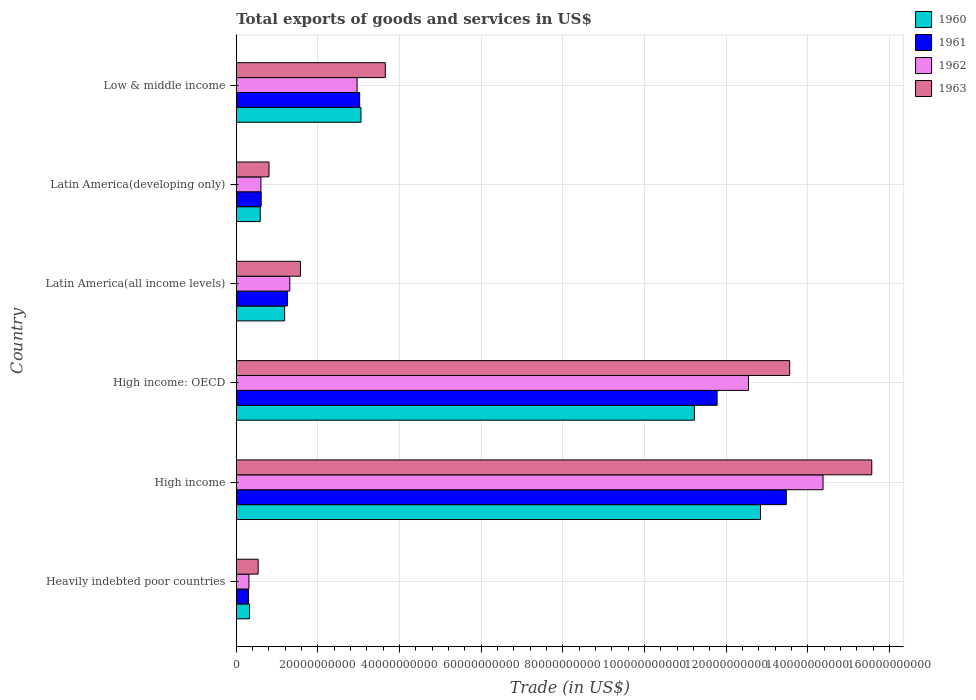Are the number of bars on each tick of the Y-axis equal?
Provide a short and direct response. Yes. How many bars are there on the 2nd tick from the top?
Offer a terse response. 4. What is the label of the 2nd group of bars from the top?
Your response must be concise. Latin America(developing only). What is the total exports of goods and services in 1963 in Latin America(developing only)?
Give a very brief answer. 8.02e+09. Across all countries, what is the maximum total exports of goods and services in 1963?
Offer a very short reply. 1.56e+11. Across all countries, what is the minimum total exports of goods and services in 1962?
Offer a terse response. 3.11e+09. In which country was the total exports of goods and services in 1960 maximum?
Offer a terse response. High income. In which country was the total exports of goods and services in 1963 minimum?
Your response must be concise. Heavily indebted poor countries. What is the total total exports of goods and services in 1961 in the graph?
Make the answer very short. 3.04e+11. What is the difference between the total exports of goods and services in 1960 in High income: OECD and that in Latin America(all income levels)?
Your answer should be very brief. 1.00e+11. What is the difference between the total exports of goods and services in 1960 in Heavily indebted poor countries and the total exports of goods and services in 1962 in Latin America(developing only)?
Provide a succinct answer. -2.79e+09. What is the average total exports of goods and services in 1963 per country?
Offer a terse response. 5.95e+1. What is the difference between the total exports of goods and services in 1961 and total exports of goods and services in 1962 in Latin America(all income levels)?
Ensure brevity in your answer.  -5.99e+08. What is the ratio of the total exports of goods and services in 1963 in Heavily indebted poor countries to that in High income: OECD?
Provide a succinct answer. 0.04. Is the difference between the total exports of goods and services in 1961 in Latin America(developing only) and Low & middle income greater than the difference between the total exports of goods and services in 1962 in Latin America(developing only) and Low & middle income?
Provide a short and direct response. No. What is the difference between the highest and the second highest total exports of goods and services in 1962?
Give a very brief answer. 1.83e+1. What is the difference between the highest and the lowest total exports of goods and services in 1961?
Your answer should be compact. 1.32e+11. In how many countries, is the total exports of goods and services in 1962 greater than the average total exports of goods and services in 1962 taken over all countries?
Ensure brevity in your answer.  2. Is the sum of the total exports of goods and services in 1963 in Latin America(all income levels) and Latin America(developing only) greater than the maximum total exports of goods and services in 1962 across all countries?
Your answer should be very brief. No. Is it the case that in every country, the sum of the total exports of goods and services in 1963 and total exports of goods and services in 1962 is greater than the sum of total exports of goods and services in 1960 and total exports of goods and services in 1961?
Provide a short and direct response. No. What does the 1st bar from the top in Latin America(developing only) represents?
Offer a terse response. 1963. What does the 2nd bar from the bottom in High income: OECD represents?
Provide a succinct answer. 1961. Is it the case that in every country, the sum of the total exports of goods and services in 1961 and total exports of goods and services in 1963 is greater than the total exports of goods and services in 1962?
Give a very brief answer. Yes. How many bars are there?
Your answer should be compact. 24. What is the difference between two consecutive major ticks on the X-axis?
Keep it short and to the point. 2.00e+1. Does the graph contain any zero values?
Ensure brevity in your answer.  No. Does the graph contain grids?
Offer a very short reply. Yes. Where does the legend appear in the graph?
Ensure brevity in your answer.  Top right. How are the legend labels stacked?
Keep it short and to the point. Vertical. What is the title of the graph?
Provide a short and direct response. Total exports of goods and services in US$. What is the label or title of the X-axis?
Ensure brevity in your answer.  Trade (in US$). What is the Trade (in US$) of 1960 in Heavily indebted poor countries?
Your response must be concise. 3.26e+09. What is the Trade (in US$) in 1961 in Heavily indebted poor countries?
Provide a succinct answer. 3.00e+09. What is the Trade (in US$) of 1962 in Heavily indebted poor countries?
Your answer should be very brief. 3.11e+09. What is the Trade (in US$) of 1963 in Heavily indebted poor countries?
Your answer should be compact. 5.37e+09. What is the Trade (in US$) of 1960 in High income?
Provide a short and direct response. 1.28e+11. What is the Trade (in US$) of 1961 in High income?
Make the answer very short. 1.35e+11. What is the Trade (in US$) of 1962 in High income?
Your answer should be very brief. 1.44e+11. What is the Trade (in US$) of 1963 in High income?
Keep it short and to the point. 1.56e+11. What is the Trade (in US$) in 1960 in High income: OECD?
Make the answer very short. 1.12e+11. What is the Trade (in US$) in 1961 in High income: OECD?
Ensure brevity in your answer.  1.18e+11. What is the Trade (in US$) in 1962 in High income: OECD?
Provide a succinct answer. 1.25e+11. What is the Trade (in US$) of 1963 in High income: OECD?
Give a very brief answer. 1.36e+11. What is the Trade (in US$) in 1960 in Latin America(all income levels)?
Make the answer very short. 1.19e+1. What is the Trade (in US$) of 1961 in Latin America(all income levels)?
Your answer should be very brief. 1.25e+1. What is the Trade (in US$) of 1962 in Latin America(all income levels)?
Your response must be concise. 1.31e+1. What is the Trade (in US$) of 1963 in Latin America(all income levels)?
Make the answer very short. 1.57e+1. What is the Trade (in US$) of 1960 in Latin America(developing only)?
Your response must be concise. 5.88e+09. What is the Trade (in US$) in 1961 in Latin America(developing only)?
Your answer should be compact. 6.11e+09. What is the Trade (in US$) in 1962 in Latin America(developing only)?
Offer a very short reply. 6.04e+09. What is the Trade (in US$) in 1963 in Latin America(developing only)?
Keep it short and to the point. 8.02e+09. What is the Trade (in US$) in 1960 in Low & middle income?
Provide a short and direct response. 3.06e+1. What is the Trade (in US$) of 1961 in Low & middle income?
Your answer should be compact. 3.02e+1. What is the Trade (in US$) of 1962 in Low & middle income?
Give a very brief answer. 2.96e+1. What is the Trade (in US$) of 1963 in Low & middle income?
Your response must be concise. 3.65e+1. Across all countries, what is the maximum Trade (in US$) in 1960?
Your answer should be very brief. 1.28e+11. Across all countries, what is the maximum Trade (in US$) of 1961?
Your answer should be compact. 1.35e+11. Across all countries, what is the maximum Trade (in US$) in 1962?
Provide a short and direct response. 1.44e+11. Across all countries, what is the maximum Trade (in US$) in 1963?
Ensure brevity in your answer.  1.56e+11. Across all countries, what is the minimum Trade (in US$) of 1960?
Give a very brief answer. 3.26e+09. Across all countries, what is the minimum Trade (in US$) of 1961?
Your answer should be compact. 3.00e+09. Across all countries, what is the minimum Trade (in US$) of 1962?
Offer a terse response. 3.11e+09. Across all countries, what is the minimum Trade (in US$) of 1963?
Provide a short and direct response. 5.37e+09. What is the total Trade (in US$) in 1960 in the graph?
Offer a terse response. 2.92e+11. What is the total Trade (in US$) in 1961 in the graph?
Offer a terse response. 3.04e+11. What is the total Trade (in US$) of 1962 in the graph?
Your answer should be compact. 3.21e+11. What is the total Trade (in US$) of 1963 in the graph?
Provide a short and direct response. 3.57e+11. What is the difference between the Trade (in US$) of 1960 in Heavily indebted poor countries and that in High income?
Keep it short and to the point. -1.25e+11. What is the difference between the Trade (in US$) in 1961 in Heavily indebted poor countries and that in High income?
Your answer should be very brief. -1.32e+11. What is the difference between the Trade (in US$) of 1962 in Heavily indebted poor countries and that in High income?
Give a very brief answer. -1.41e+11. What is the difference between the Trade (in US$) in 1963 in Heavily indebted poor countries and that in High income?
Your answer should be very brief. -1.50e+11. What is the difference between the Trade (in US$) in 1960 in Heavily indebted poor countries and that in High income: OECD?
Provide a succinct answer. -1.09e+11. What is the difference between the Trade (in US$) in 1961 in Heavily indebted poor countries and that in High income: OECD?
Offer a terse response. -1.15e+11. What is the difference between the Trade (in US$) of 1962 in Heavily indebted poor countries and that in High income: OECD?
Keep it short and to the point. -1.22e+11. What is the difference between the Trade (in US$) of 1963 in Heavily indebted poor countries and that in High income: OECD?
Make the answer very short. -1.30e+11. What is the difference between the Trade (in US$) in 1960 in Heavily indebted poor countries and that in Latin America(all income levels)?
Your response must be concise. -8.60e+09. What is the difference between the Trade (in US$) in 1961 in Heavily indebted poor countries and that in Latin America(all income levels)?
Ensure brevity in your answer.  -9.53e+09. What is the difference between the Trade (in US$) in 1962 in Heavily indebted poor countries and that in Latin America(all income levels)?
Make the answer very short. -1.00e+1. What is the difference between the Trade (in US$) of 1963 in Heavily indebted poor countries and that in Latin America(all income levels)?
Offer a terse response. -1.04e+1. What is the difference between the Trade (in US$) in 1960 in Heavily indebted poor countries and that in Latin America(developing only)?
Give a very brief answer. -2.62e+09. What is the difference between the Trade (in US$) of 1961 in Heavily indebted poor countries and that in Latin America(developing only)?
Your answer should be very brief. -3.11e+09. What is the difference between the Trade (in US$) of 1962 in Heavily indebted poor countries and that in Latin America(developing only)?
Your response must be concise. -2.94e+09. What is the difference between the Trade (in US$) of 1963 in Heavily indebted poor countries and that in Latin America(developing only)?
Give a very brief answer. -2.66e+09. What is the difference between the Trade (in US$) in 1960 in Heavily indebted poor countries and that in Low & middle income?
Provide a short and direct response. -2.73e+1. What is the difference between the Trade (in US$) of 1961 in Heavily indebted poor countries and that in Low & middle income?
Your answer should be very brief. -2.72e+1. What is the difference between the Trade (in US$) in 1962 in Heavily indebted poor countries and that in Low & middle income?
Your answer should be compact. -2.65e+1. What is the difference between the Trade (in US$) in 1963 in Heavily indebted poor countries and that in Low & middle income?
Give a very brief answer. -3.11e+1. What is the difference between the Trade (in US$) of 1960 in High income and that in High income: OECD?
Provide a succinct answer. 1.62e+1. What is the difference between the Trade (in US$) in 1961 in High income and that in High income: OECD?
Ensure brevity in your answer.  1.70e+1. What is the difference between the Trade (in US$) in 1962 in High income and that in High income: OECD?
Make the answer very short. 1.83e+1. What is the difference between the Trade (in US$) of 1963 in High income and that in High income: OECD?
Your answer should be compact. 2.01e+1. What is the difference between the Trade (in US$) in 1960 in High income and that in Latin America(all income levels)?
Give a very brief answer. 1.17e+11. What is the difference between the Trade (in US$) of 1961 in High income and that in Latin America(all income levels)?
Make the answer very short. 1.22e+11. What is the difference between the Trade (in US$) of 1962 in High income and that in Latin America(all income levels)?
Your response must be concise. 1.31e+11. What is the difference between the Trade (in US$) of 1963 in High income and that in Latin America(all income levels)?
Offer a very short reply. 1.40e+11. What is the difference between the Trade (in US$) in 1960 in High income and that in Latin America(developing only)?
Your response must be concise. 1.23e+11. What is the difference between the Trade (in US$) of 1961 in High income and that in Latin America(developing only)?
Your answer should be very brief. 1.29e+11. What is the difference between the Trade (in US$) of 1962 in High income and that in Latin America(developing only)?
Offer a very short reply. 1.38e+11. What is the difference between the Trade (in US$) in 1963 in High income and that in Latin America(developing only)?
Your answer should be very brief. 1.48e+11. What is the difference between the Trade (in US$) in 1960 in High income and that in Low & middle income?
Ensure brevity in your answer.  9.79e+1. What is the difference between the Trade (in US$) in 1961 in High income and that in Low & middle income?
Your answer should be very brief. 1.05e+11. What is the difference between the Trade (in US$) of 1962 in High income and that in Low & middle income?
Give a very brief answer. 1.14e+11. What is the difference between the Trade (in US$) of 1963 in High income and that in Low & middle income?
Keep it short and to the point. 1.19e+11. What is the difference between the Trade (in US$) in 1960 in High income: OECD and that in Latin America(all income levels)?
Offer a very short reply. 1.00e+11. What is the difference between the Trade (in US$) of 1961 in High income: OECD and that in Latin America(all income levels)?
Provide a short and direct response. 1.05e+11. What is the difference between the Trade (in US$) in 1962 in High income: OECD and that in Latin America(all income levels)?
Make the answer very short. 1.12e+11. What is the difference between the Trade (in US$) of 1963 in High income: OECD and that in Latin America(all income levels)?
Keep it short and to the point. 1.20e+11. What is the difference between the Trade (in US$) of 1960 in High income: OECD and that in Latin America(developing only)?
Make the answer very short. 1.06e+11. What is the difference between the Trade (in US$) in 1961 in High income: OECD and that in Latin America(developing only)?
Your answer should be very brief. 1.12e+11. What is the difference between the Trade (in US$) in 1962 in High income: OECD and that in Latin America(developing only)?
Your response must be concise. 1.19e+11. What is the difference between the Trade (in US$) in 1963 in High income: OECD and that in Latin America(developing only)?
Give a very brief answer. 1.28e+11. What is the difference between the Trade (in US$) in 1960 in High income: OECD and that in Low & middle income?
Ensure brevity in your answer.  8.17e+1. What is the difference between the Trade (in US$) in 1961 in High income: OECD and that in Low & middle income?
Provide a succinct answer. 8.76e+1. What is the difference between the Trade (in US$) of 1962 in High income: OECD and that in Low & middle income?
Give a very brief answer. 9.59e+1. What is the difference between the Trade (in US$) of 1963 in High income: OECD and that in Low & middle income?
Ensure brevity in your answer.  9.91e+1. What is the difference between the Trade (in US$) in 1960 in Latin America(all income levels) and that in Latin America(developing only)?
Your answer should be very brief. 5.98e+09. What is the difference between the Trade (in US$) in 1961 in Latin America(all income levels) and that in Latin America(developing only)?
Give a very brief answer. 6.42e+09. What is the difference between the Trade (in US$) in 1962 in Latin America(all income levels) and that in Latin America(developing only)?
Ensure brevity in your answer.  7.08e+09. What is the difference between the Trade (in US$) in 1963 in Latin America(all income levels) and that in Latin America(developing only)?
Make the answer very short. 7.71e+09. What is the difference between the Trade (in US$) of 1960 in Latin America(all income levels) and that in Low & middle income?
Provide a short and direct response. -1.87e+1. What is the difference between the Trade (in US$) in 1961 in Latin America(all income levels) and that in Low & middle income?
Offer a very short reply. -1.77e+1. What is the difference between the Trade (in US$) of 1962 in Latin America(all income levels) and that in Low & middle income?
Make the answer very short. -1.65e+1. What is the difference between the Trade (in US$) of 1963 in Latin America(all income levels) and that in Low & middle income?
Your answer should be compact. -2.08e+1. What is the difference between the Trade (in US$) of 1960 in Latin America(developing only) and that in Low & middle income?
Your answer should be compact. -2.47e+1. What is the difference between the Trade (in US$) of 1961 in Latin America(developing only) and that in Low & middle income?
Provide a short and direct response. -2.41e+1. What is the difference between the Trade (in US$) in 1962 in Latin America(developing only) and that in Low & middle income?
Ensure brevity in your answer.  -2.36e+1. What is the difference between the Trade (in US$) in 1963 in Latin America(developing only) and that in Low & middle income?
Make the answer very short. -2.85e+1. What is the difference between the Trade (in US$) in 1960 in Heavily indebted poor countries and the Trade (in US$) in 1961 in High income?
Give a very brief answer. -1.32e+11. What is the difference between the Trade (in US$) in 1960 in Heavily indebted poor countries and the Trade (in US$) in 1962 in High income?
Your answer should be compact. -1.40e+11. What is the difference between the Trade (in US$) in 1960 in Heavily indebted poor countries and the Trade (in US$) in 1963 in High income?
Your answer should be very brief. -1.52e+11. What is the difference between the Trade (in US$) in 1961 in Heavily indebted poor countries and the Trade (in US$) in 1962 in High income?
Keep it short and to the point. -1.41e+11. What is the difference between the Trade (in US$) of 1961 in Heavily indebted poor countries and the Trade (in US$) of 1963 in High income?
Your response must be concise. -1.53e+11. What is the difference between the Trade (in US$) in 1962 in Heavily indebted poor countries and the Trade (in US$) in 1963 in High income?
Offer a terse response. -1.53e+11. What is the difference between the Trade (in US$) of 1960 in Heavily indebted poor countries and the Trade (in US$) of 1961 in High income: OECD?
Your answer should be very brief. -1.15e+11. What is the difference between the Trade (in US$) of 1960 in Heavily indebted poor countries and the Trade (in US$) of 1962 in High income: OECD?
Ensure brevity in your answer.  -1.22e+11. What is the difference between the Trade (in US$) of 1960 in Heavily indebted poor countries and the Trade (in US$) of 1963 in High income: OECD?
Offer a terse response. -1.32e+11. What is the difference between the Trade (in US$) in 1961 in Heavily indebted poor countries and the Trade (in US$) in 1962 in High income: OECD?
Offer a terse response. -1.22e+11. What is the difference between the Trade (in US$) of 1961 in Heavily indebted poor countries and the Trade (in US$) of 1963 in High income: OECD?
Provide a succinct answer. -1.33e+11. What is the difference between the Trade (in US$) in 1962 in Heavily indebted poor countries and the Trade (in US$) in 1963 in High income: OECD?
Your answer should be very brief. -1.32e+11. What is the difference between the Trade (in US$) in 1960 in Heavily indebted poor countries and the Trade (in US$) in 1961 in Latin America(all income levels)?
Provide a short and direct response. -9.27e+09. What is the difference between the Trade (in US$) in 1960 in Heavily indebted poor countries and the Trade (in US$) in 1962 in Latin America(all income levels)?
Make the answer very short. -9.87e+09. What is the difference between the Trade (in US$) of 1960 in Heavily indebted poor countries and the Trade (in US$) of 1963 in Latin America(all income levels)?
Your answer should be compact. -1.25e+1. What is the difference between the Trade (in US$) in 1961 in Heavily indebted poor countries and the Trade (in US$) in 1962 in Latin America(all income levels)?
Keep it short and to the point. -1.01e+1. What is the difference between the Trade (in US$) of 1961 in Heavily indebted poor countries and the Trade (in US$) of 1963 in Latin America(all income levels)?
Give a very brief answer. -1.27e+1. What is the difference between the Trade (in US$) of 1962 in Heavily indebted poor countries and the Trade (in US$) of 1963 in Latin America(all income levels)?
Offer a terse response. -1.26e+1. What is the difference between the Trade (in US$) in 1960 in Heavily indebted poor countries and the Trade (in US$) in 1961 in Latin America(developing only)?
Offer a very short reply. -2.85e+09. What is the difference between the Trade (in US$) in 1960 in Heavily indebted poor countries and the Trade (in US$) in 1962 in Latin America(developing only)?
Your answer should be compact. -2.79e+09. What is the difference between the Trade (in US$) in 1960 in Heavily indebted poor countries and the Trade (in US$) in 1963 in Latin America(developing only)?
Your answer should be compact. -4.77e+09. What is the difference between the Trade (in US$) in 1961 in Heavily indebted poor countries and the Trade (in US$) in 1962 in Latin America(developing only)?
Keep it short and to the point. -3.05e+09. What is the difference between the Trade (in US$) in 1961 in Heavily indebted poor countries and the Trade (in US$) in 1963 in Latin America(developing only)?
Ensure brevity in your answer.  -5.03e+09. What is the difference between the Trade (in US$) in 1962 in Heavily indebted poor countries and the Trade (in US$) in 1963 in Latin America(developing only)?
Make the answer very short. -4.92e+09. What is the difference between the Trade (in US$) of 1960 in Heavily indebted poor countries and the Trade (in US$) of 1961 in Low & middle income?
Provide a short and direct response. -2.70e+1. What is the difference between the Trade (in US$) in 1960 in Heavily indebted poor countries and the Trade (in US$) in 1962 in Low & middle income?
Give a very brief answer. -2.63e+1. What is the difference between the Trade (in US$) of 1960 in Heavily indebted poor countries and the Trade (in US$) of 1963 in Low & middle income?
Your answer should be very brief. -3.33e+1. What is the difference between the Trade (in US$) of 1961 in Heavily indebted poor countries and the Trade (in US$) of 1962 in Low & middle income?
Give a very brief answer. -2.66e+1. What is the difference between the Trade (in US$) in 1961 in Heavily indebted poor countries and the Trade (in US$) in 1963 in Low & middle income?
Your answer should be compact. -3.35e+1. What is the difference between the Trade (in US$) in 1962 in Heavily indebted poor countries and the Trade (in US$) in 1963 in Low & middle income?
Provide a succinct answer. -3.34e+1. What is the difference between the Trade (in US$) of 1960 in High income and the Trade (in US$) of 1961 in High income: OECD?
Give a very brief answer. 1.06e+1. What is the difference between the Trade (in US$) of 1960 in High income and the Trade (in US$) of 1962 in High income: OECD?
Offer a terse response. 2.94e+09. What is the difference between the Trade (in US$) in 1960 in High income and the Trade (in US$) in 1963 in High income: OECD?
Your response must be concise. -7.15e+09. What is the difference between the Trade (in US$) in 1961 in High income and the Trade (in US$) in 1962 in High income: OECD?
Provide a short and direct response. 9.27e+09. What is the difference between the Trade (in US$) in 1961 in High income and the Trade (in US$) in 1963 in High income: OECD?
Offer a very short reply. -8.24e+08. What is the difference between the Trade (in US$) in 1962 in High income and the Trade (in US$) in 1963 in High income: OECD?
Offer a terse response. 8.17e+09. What is the difference between the Trade (in US$) of 1960 in High income and the Trade (in US$) of 1961 in Latin America(all income levels)?
Provide a short and direct response. 1.16e+11. What is the difference between the Trade (in US$) in 1960 in High income and the Trade (in US$) in 1962 in Latin America(all income levels)?
Make the answer very short. 1.15e+11. What is the difference between the Trade (in US$) of 1960 in High income and the Trade (in US$) of 1963 in Latin America(all income levels)?
Ensure brevity in your answer.  1.13e+11. What is the difference between the Trade (in US$) of 1961 in High income and the Trade (in US$) of 1962 in Latin America(all income levels)?
Make the answer very short. 1.22e+11. What is the difference between the Trade (in US$) of 1961 in High income and the Trade (in US$) of 1963 in Latin America(all income levels)?
Your answer should be compact. 1.19e+11. What is the difference between the Trade (in US$) of 1962 in High income and the Trade (in US$) of 1963 in Latin America(all income levels)?
Give a very brief answer. 1.28e+11. What is the difference between the Trade (in US$) in 1960 in High income and the Trade (in US$) in 1961 in Latin America(developing only)?
Provide a short and direct response. 1.22e+11. What is the difference between the Trade (in US$) in 1960 in High income and the Trade (in US$) in 1962 in Latin America(developing only)?
Offer a terse response. 1.22e+11. What is the difference between the Trade (in US$) in 1960 in High income and the Trade (in US$) in 1963 in Latin America(developing only)?
Keep it short and to the point. 1.20e+11. What is the difference between the Trade (in US$) of 1961 in High income and the Trade (in US$) of 1962 in Latin America(developing only)?
Your answer should be very brief. 1.29e+11. What is the difference between the Trade (in US$) of 1961 in High income and the Trade (in US$) of 1963 in Latin America(developing only)?
Provide a succinct answer. 1.27e+11. What is the difference between the Trade (in US$) in 1962 in High income and the Trade (in US$) in 1963 in Latin America(developing only)?
Provide a succinct answer. 1.36e+11. What is the difference between the Trade (in US$) of 1960 in High income and the Trade (in US$) of 1961 in Low & middle income?
Keep it short and to the point. 9.82e+1. What is the difference between the Trade (in US$) of 1960 in High income and the Trade (in US$) of 1962 in Low & middle income?
Give a very brief answer. 9.88e+1. What is the difference between the Trade (in US$) of 1960 in High income and the Trade (in US$) of 1963 in Low & middle income?
Your answer should be very brief. 9.19e+1. What is the difference between the Trade (in US$) of 1961 in High income and the Trade (in US$) of 1962 in Low & middle income?
Offer a terse response. 1.05e+11. What is the difference between the Trade (in US$) in 1961 in High income and the Trade (in US$) in 1963 in Low & middle income?
Your answer should be compact. 9.82e+1. What is the difference between the Trade (in US$) in 1962 in High income and the Trade (in US$) in 1963 in Low & middle income?
Give a very brief answer. 1.07e+11. What is the difference between the Trade (in US$) of 1960 in High income: OECD and the Trade (in US$) of 1961 in Latin America(all income levels)?
Your answer should be compact. 9.97e+1. What is the difference between the Trade (in US$) in 1960 in High income: OECD and the Trade (in US$) in 1962 in Latin America(all income levels)?
Your response must be concise. 9.91e+1. What is the difference between the Trade (in US$) of 1960 in High income: OECD and the Trade (in US$) of 1963 in Latin America(all income levels)?
Offer a very short reply. 9.65e+1. What is the difference between the Trade (in US$) of 1961 in High income: OECD and the Trade (in US$) of 1962 in Latin America(all income levels)?
Offer a terse response. 1.05e+11. What is the difference between the Trade (in US$) in 1961 in High income: OECD and the Trade (in US$) in 1963 in Latin America(all income levels)?
Your answer should be very brief. 1.02e+11. What is the difference between the Trade (in US$) in 1962 in High income: OECD and the Trade (in US$) in 1963 in Latin America(all income levels)?
Make the answer very short. 1.10e+11. What is the difference between the Trade (in US$) in 1960 in High income: OECD and the Trade (in US$) in 1961 in Latin America(developing only)?
Provide a short and direct response. 1.06e+11. What is the difference between the Trade (in US$) of 1960 in High income: OECD and the Trade (in US$) of 1962 in Latin America(developing only)?
Provide a short and direct response. 1.06e+11. What is the difference between the Trade (in US$) of 1960 in High income: OECD and the Trade (in US$) of 1963 in Latin America(developing only)?
Ensure brevity in your answer.  1.04e+11. What is the difference between the Trade (in US$) of 1961 in High income: OECD and the Trade (in US$) of 1962 in Latin America(developing only)?
Make the answer very short. 1.12e+11. What is the difference between the Trade (in US$) in 1961 in High income: OECD and the Trade (in US$) in 1963 in Latin America(developing only)?
Give a very brief answer. 1.10e+11. What is the difference between the Trade (in US$) in 1962 in High income: OECD and the Trade (in US$) in 1963 in Latin America(developing only)?
Provide a short and direct response. 1.17e+11. What is the difference between the Trade (in US$) of 1960 in High income: OECD and the Trade (in US$) of 1961 in Low & middle income?
Your answer should be very brief. 8.20e+1. What is the difference between the Trade (in US$) of 1960 in High income: OECD and the Trade (in US$) of 1962 in Low & middle income?
Ensure brevity in your answer.  8.26e+1. What is the difference between the Trade (in US$) in 1960 in High income: OECD and the Trade (in US$) in 1963 in Low & middle income?
Ensure brevity in your answer.  7.57e+1. What is the difference between the Trade (in US$) in 1961 in High income: OECD and the Trade (in US$) in 1962 in Low & middle income?
Make the answer very short. 8.82e+1. What is the difference between the Trade (in US$) in 1961 in High income: OECD and the Trade (in US$) in 1963 in Low & middle income?
Provide a succinct answer. 8.13e+1. What is the difference between the Trade (in US$) of 1962 in High income: OECD and the Trade (in US$) of 1963 in Low & middle income?
Keep it short and to the point. 8.90e+1. What is the difference between the Trade (in US$) in 1960 in Latin America(all income levels) and the Trade (in US$) in 1961 in Latin America(developing only)?
Make the answer very short. 5.74e+09. What is the difference between the Trade (in US$) of 1960 in Latin America(all income levels) and the Trade (in US$) of 1962 in Latin America(developing only)?
Give a very brief answer. 5.81e+09. What is the difference between the Trade (in US$) of 1960 in Latin America(all income levels) and the Trade (in US$) of 1963 in Latin America(developing only)?
Provide a succinct answer. 3.83e+09. What is the difference between the Trade (in US$) in 1961 in Latin America(all income levels) and the Trade (in US$) in 1962 in Latin America(developing only)?
Provide a short and direct response. 6.48e+09. What is the difference between the Trade (in US$) of 1961 in Latin America(all income levels) and the Trade (in US$) of 1963 in Latin America(developing only)?
Provide a succinct answer. 4.50e+09. What is the difference between the Trade (in US$) in 1962 in Latin America(all income levels) and the Trade (in US$) in 1963 in Latin America(developing only)?
Your answer should be compact. 5.10e+09. What is the difference between the Trade (in US$) in 1960 in Latin America(all income levels) and the Trade (in US$) in 1961 in Low & middle income?
Offer a very short reply. -1.84e+1. What is the difference between the Trade (in US$) in 1960 in Latin America(all income levels) and the Trade (in US$) in 1962 in Low & middle income?
Provide a short and direct response. -1.78e+1. What is the difference between the Trade (in US$) of 1960 in Latin America(all income levels) and the Trade (in US$) of 1963 in Low & middle income?
Give a very brief answer. -2.47e+1. What is the difference between the Trade (in US$) of 1961 in Latin America(all income levels) and the Trade (in US$) of 1962 in Low & middle income?
Give a very brief answer. -1.71e+1. What is the difference between the Trade (in US$) in 1961 in Latin America(all income levels) and the Trade (in US$) in 1963 in Low & middle income?
Your response must be concise. -2.40e+1. What is the difference between the Trade (in US$) in 1962 in Latin America(all income levels) and the Trade (in US$) in 1963 in Low & middle income?
Your answer should be compact. -2.34e+1. What is the difference between the Trade (in US$) of 1960 in Latin America(developing only) and the Trade (in US$) of 1961 in Low & middle income?
Provide a short and direct response. -2.43e+1. What is the difference between the Trade (in US$) in 1960 in Latin America(developing only) and the Trade (in US$) in 1962 in Low & middle income?
Keep it short and to the point. -2.37e+1. What is the difference between the Trade (in US$) of 1960 in Latin America(developing only) and the Trade (in US$) of 1963 in Low & middle income?
Provide a short and direct response. -3.06e+1. What is the difference between the Trade (in US$) of 1961 in Latin America(developing only) and the Trade (in US$) of 1962 in Low & middle income?
Your answer should be compact. -2.35e+1. What is the difference between the Trade (in US$) in 1961 in Latin America(developing only) and the Trade (in US$) in 1963 in Low & middle income?
Provide a succinct answer. -3.04e+1. What is the difference between the Trade (in US$) in 1962 in Latin America(developing only) and the Trade (in US$) in 1963 in Low & middle income?
Make the answer very short. -3.05e+1. What is the average Trade (in US$) of 1960 per country?
Offer a terse response. 4.87e+1. What is the average Trade (in US$) of 1961 per country?
Offer a very short reply. 5.07e+1. What is the average Trade (in US$) in 1962 per country?
Provide a short and direct response. 5.35e+1. What is the average Trade (in US$) in 1963 per country?
Offer a very short reply. 5.95e+1. What is the difference between the Trade (in US$) in 1960 and Trade (in US$) in 1961 in Heavily indebted poor countries?
Offer a very short reply. 2.58e+08. What is the difference between the Trade (in US$) of 1960 and Trade (in US$) of 1962 in Heavily indebted poor countries?
Make the answer very short. 1.48e+08. What is the difference between the Trade (in US$) of 1960 and Trade (in US$) of 1963 in Heavily indebted poor countries?
Give a very brief answer. -2.11e+09. What is the difference between the Trade (in US$) of 1961 and Trade (in US$) of 1962 in Heavily indebted poor countries?
Offer a very short reply. -1.10e+08. What is the difference between the Trade (in US$) in 1961 and Trade (in US$) in 1963 in Heavily indebted poor countries?
Your response must be concise. -2.37e+09. What is the difference between the Trade (in US$) of 1962 and Trade (in US$) of 1963 in Heavily indebted poor countries?
Keep it short and to the point. -2.26e+09. What is the difference between the Trade (in US$) of 1960 and Trade (in US$) of 1961 in High income?
Keep it short and to the point. -6.33e+09. What is the difference between the Trade (in US$) in 1960 and Trade (in US$) in 1962 in High income?
Provide a succinct answer. -1.53e+1. What is the difference between the Trade (in US$) of 1960 and Trade (in US$) of 1963 in High income?
Ensure brevity in your answer.  -2.73e+1. What is the difference between the Trade (in US$) in 1961 and Trade (in US$) in 1962 in High income?
Keep it short and to the point. -9.00e+09. What is the difference between the Trade (in US$) in 1961 and Trade (in US$) in 1963 in High income?
Provide a succinct answer. -2.09e+1. What is the difference between the Trade (in US$) of 1962 and Trade (in US$) of 1963 in High income?
Make the answer very short. -1.19e+1. What is the difference between the Trade (in US$) of 1960 and Trade (in US$) of 1961 in High income: OECD?
Keep it short and to the point. -5.56e+09. What is the difference between the Trade (in US$) in 1960 and Trade (in US$) in 1962 in High income: OECD?
Offer a very short reply. -1.33e+1. What is the difference between the Trade (in US$) of 1960 and Trade (in US$) of 1963 in High income: OECD?
Offer a very short reply. -2.33e+1. What is the difference between the Trade (in US$) in 1961 and Trade (in US$) in 1962 in High income: OECD?
Keep it short and to the point. -7.69e+09. What is the difference between the Trade (in US$) in 1961 and Trade (in US$) in 1963 in High income: OECD?
Provide a succinct answer. -1.78e+1. What is the difference between the Trade (in US$) in 1962 and Trade (in US$) in 1963 in High income: OECD?
Your answer should be compact. -1.01e+1. What is the difference between the Trade (in US$) in 1960 and Trade (in US$) in 1961 in Latin America(all income levels)?
Offer a very short reply. -6.71e+08. What is the difference between the Trade (in US$) of 1960 and Trade (in US$) of 1962 in Latin America(all income levels)?
Offer a very short reply. -1.27e+09. What is the difference between the Trade (in US$) of 1960 and Trade (in US$) of 1963 in Latin America(all income levels)?
Your answer should be very brief. -3.88e+09. What is the difference between the Trade (in US$) in 1961 and Trade (in US$) in 1962 in Latin America(all income levels)?
Your response must be concise. -5.99e+08. What is the difference between the Trade (in US$) of 1961 and Trade (in US$) of 1963 in Latin America(all income levels)?
Offer a terse response. -3.21e+09. What is the difference between the Trade (in US$) in 1962 and Trade (in US$) in 1963 in Latin America(all income levels)?
Make the answer very short. -2.61e+09. What is the difference between the Trade (in US$) in 1960 and Trade (in US$) in 1961 in Latin America(developing only)?
Make the answer very short. -2.30e+08. What is the difference between the Trade (in US$) in 1960 and Trade (in US$) in 1962 in Latin America(developing only)?
Offer a very short reply. -1.67e+08. What is the difference between the Trade (in US$) in 1960 and Trade (in US$) in 1963 in Latin America(developing only)?
Your answer should be very brief. -2.15e+09. What is the difference between the Trade (in US$) of 1961 and Trade (in US$) of 1962 in Latin America(developing only)?
Give a very brief answer. 6.28e+07. What is the difference between the Trade (in US$) of 1961 and Trade (in US$) of 1963 in Latin America(developing only)?
Your answer should be compact. -1.92e+09. What is the difference between the Trade (in US$) of 1962 and Trade (in US$) of 1963 in Latin America(developing only)?
Your answer should be compact. -1.98e+09. What is the difference between the Trade (in US$) in 1960 and Trade (in US$) in 1961 in Low & middle income?
Your answer should be very brief. 3.25e+08. What is the difference between the Trade (in US$) in 1960 and Trade (in US$) in 1962 in Low & middle income?
Your answer should be very brief. 9.47e+08. What is the difference between the Trade (in US$) of 1960 and Trade (in US$) of 1963 in Low & middle income?
Provide a short and direct response. -5.96e+09. What is the difference between the Trade (in US$) in 1961 and Trade (in US$) in 1962 in Low & middle income?
Provide a succinct answer. 6.22e+08. What is the difference between the Trade (in US$) of 1961 and Trade (in US$) of 1963 in Low & middle income?
Offer a very short reply. -6.29e+09. What is the difference between the Trade (in US$) of 1962 and Trade (in US$) of 1963 in Low & middle income?
Keep it short and to the point. -6.91e+09. What is the ratio of the Trade (in US$) in 1960 in Heavily indebted poor countries to that in High income?
Your answer should be very brief. 0.03. What is the ratio of the Trade (in US$) in 1961 in Heavily indebted poor countries to that in High income?
Provide a short and direct response. 0.02. What is the ratio of the Trade (in US$) in 1962 in Heavily indebted poor countries to that in High income?
Your answer should be compact. 0.02. What is the ratio of the Trade (in US$) of 1963 in Heavily indebted poor countries to that in High income?
Provide a short and direct response. 0.03. What is the ratio of the Trade (in US$) in 1960 in Heavily indebted poor countries to that in High income: OECD?
Make the answer very short. 0.03. What is the ratio of the Trade (in US$) in 1961 in Heavily indebted poor countries to that in High income: OECD?
Your answer should be very brief. 0.03. What is the ratio of the Trade (in US$) of 1962 in Heavily indebted poor countries to that in High income: OECD?
Ensure brevity in your answer.  0.02. What is the ratio of the Trade (in US$) of 1963 in Heavily indebted poor countries to that in High income: OECD?
Offer a terse response. 0.04. What is the ratio of the Trade (in US$) of 1960 in Heavily indebted poor countries to that in Latin America(all income levels)?
Provide a short and direct response. 0.27. What is the ratio of the Trade (in US$) in 1961 in Heavily indebted poor countries to that in Latin America(all income levels)?
Offer a terse response. 0.24. What is the ratio of the Trade (in US$) of 1962 in Heavily indebted poor countries to that in Latin America(all income levels)?
Your response must be concise. 0.24. What is the ratio of the Trade (in US$) in 1963 in Heavily indebted poor countries to that in Latin America(all income levels)?
Ensure brevity in your answer.  0.34. What is the ratio of the Trade (in US$) of 1960 in Heavily indebted poor countries to that in Latin America(developing only)?
Provide a short and direct response. 0.55. What is the ratio of the Trade (in US$) of 1961 in Heavily indebted poor countries to that in Latin America(developing only)?
Your answer should be very brief. 0.49. What is the ratio of the Trade (in US$) in 1962 in Heavily indebted poor countries to that in Latin America(developing only)?
Ensure brevity in your answer.  0.51. What is the ratio of the Trade (in US$) in 1963 in Heavily indebted poor countries to that in Latin America(developing only)?
Your response must be concise. 0.67. What is the ratio of the Trade (in US$) in 1960 in Heavily indebted poor countries to that in Low & middle income?
Provide a succinct answer. 0.11. What is the ratio of the Trade (in US$) in 1961 in Heavily indebted poor countries to that in Low & middle income?
Give a very brief answer. 0.1. What is the ratio of the Trade (in US$) in 1962 in Heavily indebted poor countries to that in Low & middle income?
Offer a terse response. 0.1. What is the ratio of the Trade (in US$) of 1963 in Heavily indebted poor countries to that in Low & middle income?
Offer a very short reply. 0.15. What is the ratio of the Trade (in US$) of 1960 in High income to that in High income: OECD?
Provide a short and direct response. 1.14. What is the ratio of the Trade (in US$) of 1961 in High income to that in High income: OECD?
Your answer should be very brief. 1.14. What is the ratio of the Trade (in US$) in 1962 in High income to that in High income: OECD?
Provide a succinct answer. 1.15. What is the ratio of the Trade (in US$) of 1963 in High income to that in High income: OECD?
Your response must be concise. 1.15. What is the ratio of the Trade (in US$) of 1960 in High income to that in Latin America(all income levels)?
Your answer should be very brief. 10.84. What is the ratio of the Trade (in US$) in 1961 in High income to that in Latin America(all income levels)?
Provide a short and direct response. 10.76. What is the ratio of the Trade (in US$) of 1962 in High income to that in Latin America(all income levels)?
Offer a very short reply. 10.96. What is the ratio of the Trade (in US$) in 1963 in High income to that in Latin America(all income levels)?
Offer a very short reply. 9.89. What is the ratio of the Trade (in US$) in 1960 in High income to that in Latin America(developing only)?
Keep it short and to the point. 21.85. What is the ratio of the Trade (in US$) in 1961 in High income to that in Latin America(developing only)?
Provide a succinct answer. 22.06. What is the ratio of the Trade (in US$) of 1962 in High income to that in Latin America(developing only)?
Ensure brevity in your answer.  23.78. What is the ratio of the Trade (in US$) of 1963 in High income to that in Latin America(developing only)?
Offer a terse response. 19.4. What is the ratio of the Trade (in US$) of 1960 in High income to that in Low & middle income?
Provide a short and direct response. 4.2. What is the ratio of the Trade (in US$) of 1961 in High income to that in Low & middle income?
Your answer should be very brief. 4.46. What is the ratio of the Trade (in US$) of 1962 in High income to that in Low & middle income?
Your answer should be very brief. 4.86. What is the ratio of the Trade (in US$) of 1963 in High income to that in Low & middle income?
Provide a short and direct response. 4.26. What is the ratio of the Trade (in US$) in 1960 in High income: OECD to that in Latin America(all income levels)?
Your answer should be very brief. 9.47. What is the ratio of the Trade (in US$) in 1961 in High income: OECD to that in Latin America(all income levels)?
Offer a very short reply. 9.41. What is the ratio of the Trade (in US$) in 1962 in High income: OECD to that in Latin America(all income levels)?
Your answer should be compact. 9.56. What is the ratio of the Trade (in US$) in 1963 in High income: OECD to that in Latin America(all income levels)?
Give a very brief answer. 8.62. What is the ratio of the Trade (in US$) in 1960 in High income: OECD to that in Latin America(developing only)?
Give a very brief answer. 19.1. What is the ratio of the Trade (in US$) in 1961 in High income: OECD to that in Latin America(developing only)?
Provide a succinct answer. 19.29. What is the ratio of the Trade (in US$) of 1962 in High income: OECD to that in Latin America(developing only)?
Your answer should be compact. 20.76. What is the ratio of the Trade (in US$) of 1963 in High income: OECD to that in Latin America(developing only)?
Make the answer very short. 16.9. What is the ratio of the Trade (in US$) in 1960 in High income: OECD to that in Low & middle income?
Offer a terse response. 3.67. What is the ratio of the Trade (in US$) in 1961 in High income: OECD to that in Low & middle income?
Offer a terse response. 3.9. What is the ratio of the Trade (in US$) of 1962 in High income: OECD to that in Low & middle income?
Make the answer very short. 4.24. What is the ratio of the Trade (in US$) in 1963 in High income: OECD to that in Low & middle income?
Provide a succinct answer. 3.71. What is the ratio of the Trade (in US$) of 1960 in Latin America(all income levels) to that in Latin America(developing only)?
Your response must be concise. 2.02. What is the ratio of the Trade (in US$) in 1961 in Latin America(all income levels) to that in Latin America(developing only)?
Provide a short and direct response. 2.05. What is the ratio of the Trade (in US$) of 1962 in Latin America(all income levels) to that in Latin America(developing only)?
Make the answer very short. 2.17. What is the ratio of the Trade (in US$) in 1963 in Latin America(all income levels) to that in Latin America(developing only)?
Ensure brevity in your answer.  1.96. What is the ratio of the Trade (in US$) in 1960 in Latin America(all income levels) to that in Low & middle income?
Provide a short and direct response. 0.39. What is the ratio of the Trade (in US$) of 1961 in Latin America(all income levels) to that in Low & middle income?
Your response must be concise. 0.41. What is the ratio of the Trade (in US$) of 1962 in Latin America(all income levels) to that in Low & middle income?
Provide a short and direct response. 0.44. What is the ratio of the Trade (in US$) in 1963 in Latin America(all income levels) to that in Low & middle income?
Your response must be concise. 0.43. What is the ratio of the Trade (in US$) in 1960 in Latin America(developing only) to that in Low & middle income?
Your answer should be compact. 0.19. What is the ratio of the Trade (in US$) of 1961 in Latin America(developing only) to that in Low & middle income?
Your answer should be very brief. 0.2. What is the ratio of the Trade (in US$) in 1962 in Latin America(developing only) to that in Low & middle income?
Offer a terse response. 0.2. What is the ratio of the Trade (in US$) in 1963 in Latin America(developing only) to that in Low & middle income?
Your answer should be very brief. 0.22. What is the difference between the highest and the second highest Trade (in US$) of 1960?
Give a very brief answer. 1.62e+1. What is the difference between the highest and the second highest Trade (in US$) of 1961?
Provide a succinct answer. 1.70e+1. What is the difference between the highest and the second highest Trade (in US$) of 1962?
Keep it short and to the point. 1.83e+1. What is the difference between the highest and the second highest Trade (in US$) in 1963?
Offer a terse response. 2.01e+1. What is the difference between the highest and the lowest Trade (in US$) in 1960?
Provide a succinct answer. 1.25e+11. What is the difference between the highest and the lowest Trade (in US$) of 1961?
Provide a succinct answer. 1.32e+11. What is the difference between the highest and the lowest Trade (in US$) in 1962?
Offer a terse response. 1.41e+11. What is the difference between the highest and the lowest Trade (in US$) in 1963?
Your response must be concise. 1.50e+11. 